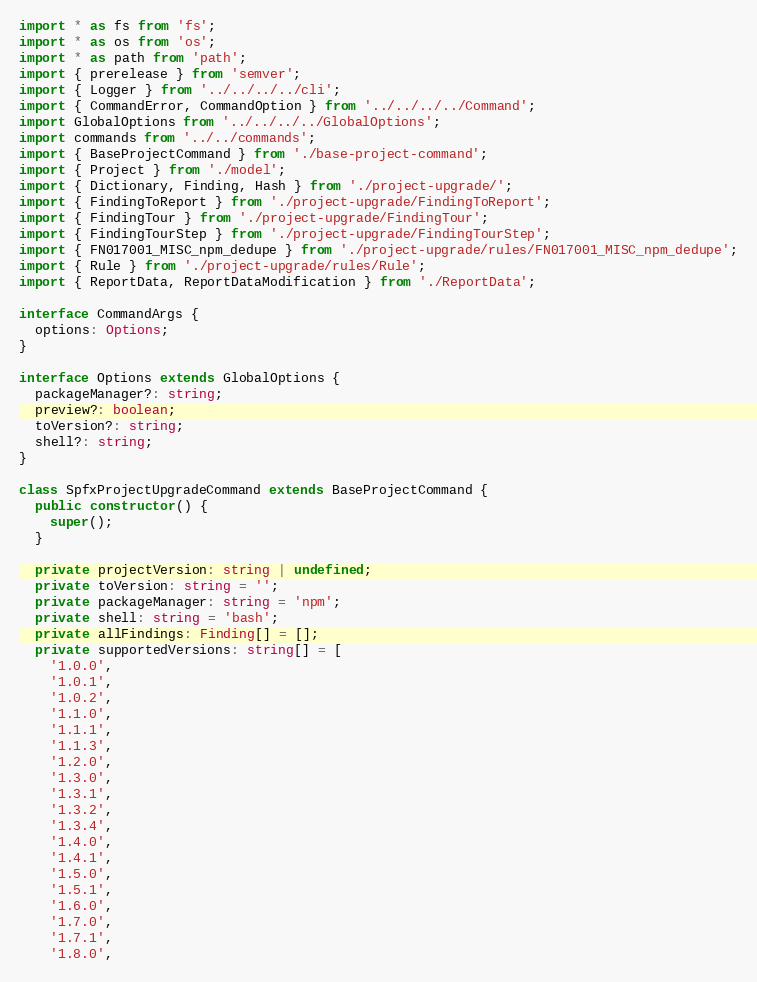<code> <loc_0><loc_0><loc_500><loc_500><_TypeScript_>import * as fs from 'fs';
import * as os from 'os';
import * as path from 'path';
import { prerelease } from 'semver';
import { Logger } from '../../../../cli';
import { CommandError, CommandOption } from '../../../../Command';
import GlobalOptions from '../../../../GlobalOptions';
import commands from '../../commands';
import { BaseProjectCommand } from './base-project-command';
import { Project } from './model';
import { Dictionary, Finding, Hash } from './project-upgrade/';
import { FindingToReport } from './project-upgrade/FindingToReport';
import { FindingTour } from './project-upgrade/FindingTour';
import { FindingTourStep } from './project-upgrade/FindingTourStep';
import { FN017001_MISC_npm_dedupe } from './project-upgrade/rules/FN017001_MISC_npm_dedupe';
import { Rule } from './project-upgrade/rules/Rule';
import { ReportData, ReportDataModification } from './ReportData';

interface CommandArgs {
  options: Options;
}

interface Options extends GlobalOptions {
  packageManager?: string;
  preview?: boolean;
  toVersion?: string;
  shell?: string;
}

class SpfxProjectUpgradeCommand extends BaseProjectCommand {
  public constructor() {
    super();
  }

  private projectVersion: string | undefined;
  private toVersion: string = '';
  private packageManager: string = 'npm';
  private shell: string = 'bash';
  private allFindings: Finding[] = [];
  private supportedVersions: string[] = [
    '1.0.0',
    '1.0.1',
    '1.0.2',
    '1.1.0',
    '1.1.1',
    '1.1.3',
    '1.2.0',
    '1.3.0',
    '1.3.1',
    '1.3.2',
    '1.3.4',
    '1.4.0',
    '1.4.1',
    '1.5.0',
    '1.5.1',
    '1.6.0',
    '1.7.0',
    '1.7.1',
    '1.8.0',</code> 